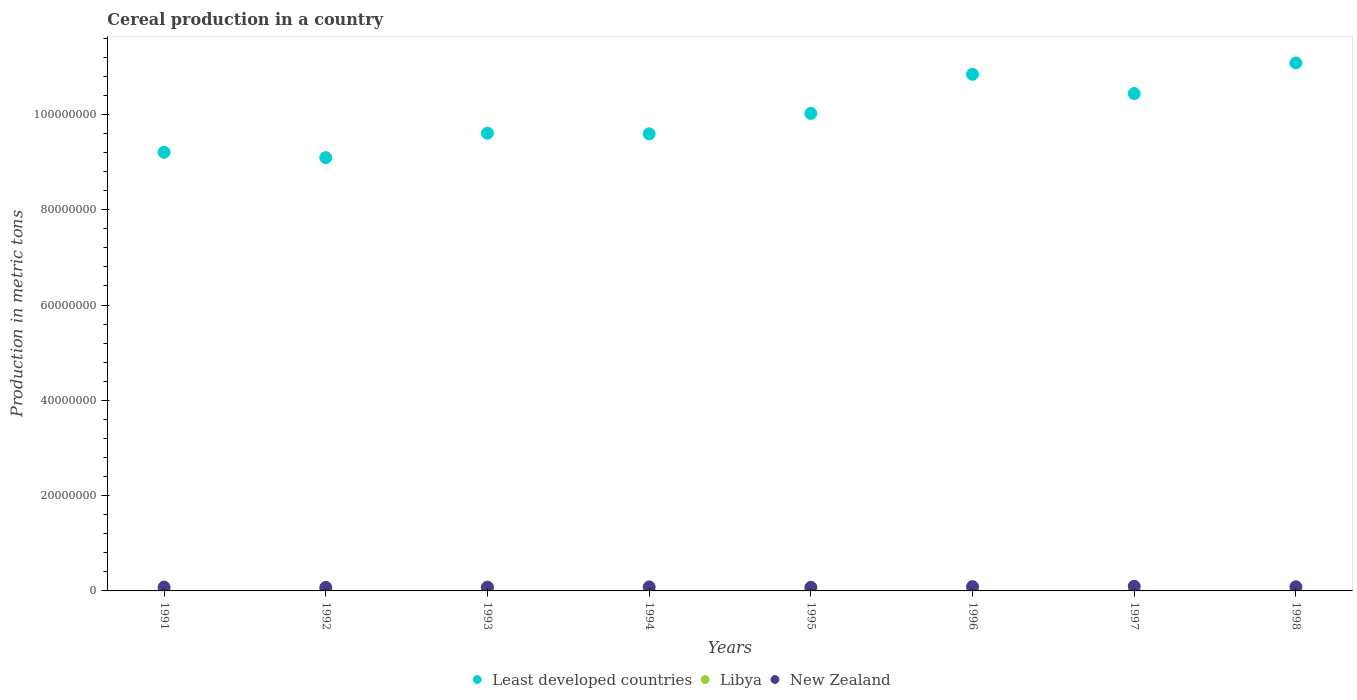Is the number of dotlines equal to the number of legend labels?
Offer a very short reply. Yes. What is the total cereal production in Libya in 1998?
Offer a very short reply. 2.13e+05. Across all years, what is the maximum total cereal production in New Zealand?
Your answer should be compact. 9.80e+05. Across all years, what is the minimum total cereal production in Least developed countries?
Your answer should be very brief. 9.09e+07. In which year was the total cereal production in Least developed countries maximum?
Provide a short and direct response. 1998. In which year was the total cereal production in Libya minimum?
Provide a succinct answer. 1995. What is the total total cereal production in New Zealand in the graph?
Make the answer very short. 6.70e+06. What is the difference between the total cereal production in Least developed countries in 1992 and that in 1997?
Offer a very short reply. -1.35e+07. What is the difference between the total cereal production in New Zealand in 1998 and the total cereal production in Libya in 1991?
Ensure brevity in your answer.  6.11e+05. What is the average total cereal production in Least developed countries per year?
Provide a succinct answer. 9.98e+07. In the year 1997, what is the difference between the total cereal production in New Zealand and total cereal production in Least developed countries?
Provide a succinct answer. -1.03e+08. What is the ratio of the total cereal production in Least developed countries in 1991 to that in 1997?
Ensure brevity in your answer.  0.88. Is the total cereal production in Libya in 1996 less than that in 1998?
Your response must be concise. Yes. What is the difference between the highest and the second highest total cereal production in New Zealand?
Offer a very short reply. 7.61e+04. What is the difference between the highest and the lowest total cereal production in Libya?
Make the answer very short. 1.12e+05. Is it the case that in every year, the sum of the total cereal production in Libya and total cereal production in New Zealand  is greater than the total cereal production in Least developed countries?
Keep it short and to the point. No. Is the total cereal production in Libya strictly greater than the total cereal production in New Zealand over the years?
Provide a short and direct response. No. How many years are there in the graph?
Make the answer very short. 8. Are the values on the major ticks of Y-axis written in scientific E-notation?
Keep it short and to the point. No. Does the graph contain any zero values?
Make the answer very short. No. How many legend labels are there?
Your response must be concise. 3. How are the legend labels stacked?
Offer a very short reply. Horizontal. What is the title of the graph?
Your response must be concise. Cereal production in a country. What is the label or title of the Y-axis?
Keep it short and to the point. Production in metric tons. What is the Production in metric tons in Least developed countries in 1991?
Give a very brief answer. 9.21e+07. What is the Production in metric tons in Libya in 1991?
Offer a very short reply. 2.58e+05. What is the Production in metric tons in New Zealand in 1991?
Make the answer very short. 8.09e+05. What is the Production in metric tons of Least developed countries in 1992?
Offer a terse response. 9.09e+07. What is the Production in metric tons of Libya in 1992?
Your answer should be compact. 2.18e+05. What is the Production in metric tons in New Zealand in 1992?
Your response must be concise. 7.36e+05. What is the Production in metric tons in Least developed countries in 1993?
Offer a terse response. 9.61e+07. What is the Production in metric tons of Libya in 1993?
Give a very brief answer. 1.80e+05. What is the Production in metric tons in New Zealand in 1993?
Offer a terse response. 8.03e+05. What is the Production in metric tons in Least developed countries in 1994?
Make the answer very short. 9.59e+07. What is the Production in metric tons in Libya in 1994?
Your answer should be compact. 1.65e+05. What is the Production in metric tons of New Zealand in 1994?
Provide a short and direct response. 8.43e+05. What is the Production in metric tons of Least developed countries in 1995?
Provide a succinct answer. 1.00e+08. What is the Production in metric tons in Libya in 1995?
Offer a terse response. 1.46e+05. What is the Production in metric tons of New Zealand in 1995?
Offer a terse response. 7.52e+05. What is the Production in metric tons in Least developed countries in 1996?
Offer a very short reply. 1.08e+08. What is the Production in metric tons of Libya in 1996?
Provide a succinct answer. 1.60e+05. What is the Production in metric tons of New Zealand in 1996?
Your response must be concise. 9.04e+05. What is the Production in metric tons of Least developed countries in 1997?
Offer a terse response. 1.04e+08. What is the Production in metric tons in Libya in 1997?
Give a very brief answer. 2.06e+05. What is the Production in metric tons in New Zealand in 1997?
Offer a terse response. 9.80e+05. What is the Production in metric tons of Least developed countries in 1998?
Your answer should be compact. 1.11e+08. What is the Production in metric tons in Libya in 1998?
Make the answer very short. 2.13e+05. What is the Production in metric tons of New Zealand in 1998?
Provide a succinct answer. 8.68e+05. Across all years, what is the maximum Production in metric tons of Least developed countries?
Your answer should be very brief. 1.11e+08. Across all years, what is the maximum Production in metric tons in Libya?
Provide a short and direct response. 2.58e+05. Across all years, what is the maximum Production in metric tons of New Zealand?
Your answer should be compact. 9.80e+05. Across all years, what is the minimum Production in metric tons in Least developed countries?
Offer a terse response. 9.09e+07. Across all years, what is the minimum Production in metric tons of Libya?
Keep it short and to the point. 1.46e+05. Across all years, what is the minimum Production in metric tons of New Zealand?
Give a very brief answer. 7.36e+05. What is the total Production in metric tons of Least developed countries in the graph?
Provide a succinct answer. 7.99e+08. What is the total Production in metric tons of Libya in the graph?
Provide a succinct answer. 1.54e+06. What is the total Production in metric tons in New Zealand in the graph?
Provide a short and direct response. 6.70e+06. What is the difference between the Production in metric tons of Least developed countries in 1991 and that in 1992?
Keep it short and to the point. 1.13e+06. What is the difference between the Production in metric tons of Libya in 1991 and that in 1992?
Your response must be concise. 4.00e+04. What is the difference between the Production in metric tons of New Zealand in 1991 and that in 1992?
Provide a succinct answer. 7.31e+04. What is the difference between the Production in metric tons in Least developed countries in 1991 and that in 1993?
Your response must be concise. -4.00e+06. What is the difference between the Production in metric tons in Libya in 1991 and that in 1993?
Offer a very short reply. 7.80e+04. What is the difference between the Production in metric tons in New Zealand in 1991 and that in 1993?
Your response must be concise. 6235. What is the difference between the Production in metric tons in Least developed countries in 1991 and that in 1994?
Ensure brevity in your answer.  -3.87e+06. What is the difference between the Production in metric tons of Libya in 1991 and that in 1994?
Your answer should be very brief. 9.31e+04. What is the difference between the Production in metric tons in New Zealand in 1991 and that in 1994?
Provide a succinct answer. -3.38e+04. What is the difference between the Production in metric tons in Least developed countries in 1991 and that in 1995?
Ensure brevity in your answer.  -8.15e+06. What is the difference between the Production in metric tons in Libya in 1991 and that in 1995?
Offer a very short reply. 1.12e+05. What is the difference between the Production in metric tons in New Zealand in 1991 and that in 1995?
Provide a short and direct response. 5.73e+04. What is the difference between the Production in metric tons of Least developed countries in 1991 and that in 1996?
Offer a terse response. -1.64e+07. What is the difference between the Production in metric tons in Libya in 1991 and that in 1996?
Your answer should be compact. 9.79e+04. What is the difference between the Production in metric tons in New Zealand in 1991 and that in 1996?
Ensure brevity in your answer.  -9.46e+04. What is the difference between the Production in metric tons in Least developed countries in 1991 and that in 1997?
Your answer should be compact. -1.23e+07. What is the difference between the Production in metric tons in Libya in 1991 and that in 1997?
Offer a terse response. 5.15e+04. What is the difference between the Production in metric tons of New Zealand in 1991 and that in 1997?
Your answer should be compact. -1.71e+05. What is the difference between the Production in metric tons in Least developed countries in 1991 and that in 1998?
Provide a succinct answer. -1.87e+07. What is the difference between the Production in metric tons in Libya in 1991 and that in 1998?
Ensure brevity in your answer.  4.50e+04. What is the difference between the Production in metric tons in New Zealand in 1991 and that in 1998?
Make the answer very short. -5.89e+04. What is the difference between the Production in metric tons in Least developed countries in 1992 and that in 1993?
Ensure brevity in your answer.  -5.12e+06. What is the difference between the Production in metric tons of Libya in 1992 and that in 1993?
Offer a very short reply. 3.81e+04. What is the difference between the Production in metric tons of New Zealand in 1992 and that in 1993?
Offer a very short reply. -6.69e+04. What is the difference between the Production in metric tons in Least developed countries in 1992 and that in 1994?
Give a very brief answer. -5.00e+06. What is the difference between the Production in metric tons of Libya in 1992 and that in 1994?
Give a very brief answer. 5.31e+04. What is the difference between the Production in metric tons in New Zealand in 1992 and that in 1994?
Offer a terse response. -1.07e+05. What is the difference between the Production in metric tons of Least developed countries in 1992 and that in 1995?
Keep it short and to the point. -9.28e+06. What is the difference between the Production in metric tons of Libya in 1992 and that in 1995?
Provide a succinct answer. 7.19e+04. What is the difference between the Production in metric tons of New Zealand in 1992 and that in 1995?
Provide a succinct answer. -1.59e+04. What is the difference between the Production in metric tons in Least developed countries in 1992 and that in 1996?
Offer a terse response. -1.75e+07. What is the difference between the Production in metric tons of Libya in 1992 and that in 1996?
Offer a terse response. 5.80e+04. What is the difference between the Production in metric tons in New Zealand in 1992 and that in 1996?
Provide a succinct answer. -1.68e+05. What is the difference between the Production in metric tons of Least developed countries in 1992 and that in 1997?
Offer a very short reply. -1.35e+07. What is the difference between the Production in metric tons of Libya in 1992 and that in 1997?
Offer a very short reply. 1.16e+04. What is the difference between the Production in metric tons of New Zealand in 1992 and that in 1997?
Your answer should be compact. -2.44e+05. What is the difference between the Production in metric tons of Least developed countries in 1992 and that in 1998?
Offer a terse response. -1.99e+07. What is the difference between the Production in metric tons in Libya in 1992 and that in 1998?
Give a very brief answer. 5061. What is the difference between the Production in metric tons of New Zealand in 1992 and that in 1998?
Offer a terse response. -1.32e+05. What is the difference between the Production in metric tons of Least developed countries in 1993 and that in 1994?
Your answer should be very brief. 1.21e+05. What is the difference between the Production in metric tons in Libya in 1993 and that in 1994?
Offer a very short reply. 1.50e+04. What is the difference between the Production in metric tons in New Zealand in 1993 and that in 1994?
Give a very brief answer. -4.00e+04. What is the difference between the Production in metric tons of Least developed countries in 1993 and that in 1995?
Your answer should be very brief. -4.15e+06. What is the difference between the Production in metric tons of Libya in 1993 and that in 1995?
Provide a short and direct response. 3.39e+04. What is the difference between the Production in metric tons in New Zealand in 1993 and that in 1995?
Provide a succinct answer. 5.11e+04. What is the difference between the Production in metric tons of Least developed countries in 1993 and that in 1996?
Your answer should be compact. -1.24e+07. What is the difference between the Production in metric tons of Libya in 1993 and that in 1996?
Your answer should be very brief. 1.99e+04. What is the difference between the Production in metric tons in New Zealand in 1993 and that in 1996?
Your answer should be very brief. -1.01e+05. What is the difference between the Production in metric tons of Least developed countries in 1993 and that in 1997?
Keep it short and to the point. -8.33e+06. What is the difference between the Production in metric tons of Libya in 1993 and that in 1997?
Offer a terse response. -2.65e+04. What is the difference between the Production in metric tons in New Zealand in 1993 and that in 1997?
Make the answer very short. -1.77e+05. What is the difference between the Production in metric tons in Least developed countries in 1993 and that in 1998?
Offer a very short reply. -1.48e+07. What is the difference between the Production in metric tons of Libya in 1993 and that in 1998?
Your response must be concise. -3.30e+04. What is the difference between the Production in metric tons in New Zealand in 1993 and that in 1998?
Your answer should be very brief. -6.52e+04. What is the difference between the Production in metric tons of Least developed countries in 1994 and that in 1995?
Your answer should be very brief. -4.28e+06. What is the difference between the Production in metric tons of Libya in 1994 and that in 1995?
Make the answer very short. 1.88e+04. What is the difference between the Production in metric tons in New Zealand in 1994 and that in 1995?
Offer a terse response. 9.11e+04. What is the difference between the Production in metric tons of Least developed countries in 1994 and that in 1996?
Ensure brevity in your answer.  -1.25e+07. What is the difference between the Production in metric tons in Libya in 1994 and that in 1996?
Your response must be concise. 4851. What is the difference between the Production in metric tons in New Zealand in 1994 and that in 1996?
Provide a short and direct response. -6.09e+04. What is the difference between the Production in metric tons in Least developed countries in 1994 and that in 1997?
Your answer should be very brief. -8.45e+06. What is the difference between the Production in metric tons of Libya in 1994 and that in 1997?
Your response must be concise. -4.15e+04. What is the difference between the Production in metric tons of New Zealand in 1994 and that in 1997?
Offer a very short reply. -1.37e+05. What is the difference between the Production in metric tons in Least developed countries in 1994 and that in 1998?
Ensure brevity in your answer.  -1.49e+07. What is the difference between the Production in metric tons in Libya in 1994 and that in 1998?
Ensure brevity in your answer.  -4.80e+04. What is the difference between the Production in metric tons of New Zealand in 1994 and that in 1998?
Provide a succinct answer. -2.52e+04. What is the difference between the Production in metric tons of Least developed countries in 1995 and that in 1996?
Provide a short and direct response. -8.21e+06. What is the difference between the Production in metric tons in Libya in 1995 and that in 1996?
Offer a terse response. -1.40e+04. What is the difference between the Production in metric tons in New Zealand in 1995 and that in 1996?
Your response must be concise. -1.52e+05. What is the difference between the Production in metric tons of Least developed countries in 1995 and that in 1997?
Ensure brevity in your answer.  -4.18e+06. What is the difference between the Production in metric tons in Libya in 1995 and that in 1997?
Provide a short and direct response. -6.04e+04. What is the difference between the Production in metric tons in New Zealand in 1995 and that in 1997?
Ensure brevity in your answer.  -2.28e+05. What is the difference between the Production in metric tons in Least developed countries in 1995 and that in 1998?
Make the answer very short. -1.06e+07. What is the difference between the Production in metric tons of Libya in 1995 and that in 1998?
Offer a very short reply. -6.69e+04. What is the difference between the Production in metric tons of New Zealand in 1995 and that in 1998?
Provide a short and direct response. -1.16e+05. What is the difference between the Production in metric tons of Least developed countries in 1996 and that in 1997?
Give a very brief answer. 4.04e+06. What is the difference between the Production in metric tons of Libya in 1996 and that in 1997?
Keep it short and to the point. -4.64e+04. What is the difference between the Production in metric tons of New Zealand in 1996 and that in 1997?
Your answer should be very brief. -7.61e+04. What is the difference between the Production in metric tons of Least developed countries in 1996 and that in 1998?
Offer a terse response. -2.39e+06. What is the difference between the Production in metric tons of Libya in 1996 and that in 1998?
Keep it short and to the point. -5.29e+04. What is the difference between the Production in metric tons in New Zealand in 1996 and that in 1998?
Keep it short and to the point. 3.57e+04. What is the difference between the Production in metric tons of Least developed countries in 1997 and that in 1998?
Your response must be concise. -6.42e+06. What is the difference between the Production in metric tons in Libya in 1997 and that in 1998?
Give a very brief answer. -6500. What is the difference between the Production in metric tons of New Zealand in 1997 and that in 1998?
Keep it short and to the point. 1.12e+05. What is the difference between the Production in metric tons of Least developed countries in 1991 and the Production in metric tons of Libya in 1992?
Offer a terse response. 9.18e+07. What is the difference between the Production in metric tons in Least developed countries in 1991 and the Production in metric tons in New Zealand in 1992?
Your response must be concise. 9.13e+07. What is the difference between the Production in metric tons in Libya in 1991 and the Production in metric tons in New Zealand in 1992?
Provide a short and direct response. -4.78e+05. What is the difference between the Production in metric tons of Least developed countries in 1991 and the Production in metric tons of Libya in 1993?
Your response must be concise. 9.19e+07. What is the difference between the Production in metric tons in Least developed countries in 1991 and the Production in metric tons in New Zealand in 1993?
Keep it short and to the point. 9.13e+07. What is the difference between the Production in metric tons in Libya in 1991 and the Production in metric tons in New Zealand in 1993?
Offer a very short reply. -5.45e+05. What is the difference between the Production in metric tons in Least developed countries in 1991 and the Production in metric tons in Libya in 1994?
Give a very brief answer. 9.19e+07. What is the difference between the Production in metric tons of Least developed countries in 1991 and the Production in metric tons of New Zealand in 1994?
Make the answer very short. 9.12e+07. What is the difference between the Production in metric tons of Libya in 1991 and the Production in metric tons of New Zealand in 1994?
Ensure brevity in your answer.  -5.85e+05. What is the difference between the Production in metric tons in Least developed countries in 1991 and the Production in metric tons in Libya in 1995?
Give a very brief answer. 9.19e+07. What is the difference between the Production in metric tons of Least developed countries in 1991 and the Production in metric tons of New Zealand in 1995?
Your response must be concise. 9.13e+07. What is the difference between the Production in metric tons of Libya in 1991 and the Production in metric tons of New Zealand in 1995?
Keep it short and to the point. -4.94e+05. What is the difference between the Production in metric tons in Least developed countries in 1991 and the Production in metric tons in Libya in 1996?
Offer a very short reply. 9.19e+07. What is the difference between the Production in metric tons of Least developed countries in 1991 and the Production in metric tons of New Zealand in 1996?
Make the answer very short. 9.12e+07. What is the difference between the Production in metric tons of Libya in 1991 and the Production in metric tons of New Zealand in 1996?
Provide a short and direct response. -6.46e+05. What is the difference between the Production in metric tons in Least developed countries in 1991 and the Production in metric tons in Libya in 1997?
Provide a short and direct response. 9.18e+07. What is the difference between the Production in metric tons in Least developed countries in 1991 and the Production in metric tons in New Zealand in 1997?
Provide a succinct answer. 9.11e+07. What is the difference between the Production in metric tons of Libya in 1991 and the Production in metric tons of New Zealand in 1997?
Provide a short and direct response. -7.22e+05. What is the difference between the Production in metric tons of Least developed countries in 1991 and the Production in metric tons of Libya in 1998?
Your response must be concise. 9.18e+07. What is the difference between the Production in metric tons in Least developed countries in 1991 and the Production in metric tons in New Zealand in 1998?
Give a very brief answer. 9.12e+07. What is the difference between the Production in metric tons of Libya in 1991 and the Production in metric tons of New Zealand in 1998?
Your answer should be compact. -6.11e+05. What is the difference between the Production in metric tons of Least developed countries in 1992 and the Production in metric tons of Libya in 1993?
Make the answer very short. 9.07e+07. What is the difference between the Production in metric tons in Least developed countries in 1992 and the Production in metric tons in New Zealand in 1993?
Your answer should be compact. 9.01e+07. What is the difference between the Production in metric tons of Libya in 1992 and the Production in metric tons of New Zealand in 1993?
Your answer should be compact. -5.85e+05. What is the difference between the Production in metric tons in Least developed countries in 1992 and the Production in metric tons in Libya in 1994?
Your answer should be very brief. 9.08e+07. What is the difference between the Production in metric tons of Least developed countries in 1992 and the Production in metric tons of New Zealand in 1994?
Provide a succinct answer. 9.01e+07. What is the difference between the Production in metric tons of Libya in 1992 and the Production in metric tons of New Zealand in 1994?
Your answer should be very brief. -6.25e+05. What is the difference between the Production in metric tons of Least developed countries in 1992 and the Production in metric tons of Libya in 1995?
Provide a short and direct response. 9.08e+07. What is the difference between the Production in metric tons in Least developed countries in 1992 and the Production in metric tons in New Zealand in 1995?
Your response must be concise. 9.02e+07. What is the difference between the Production in metric tons of Libya in 1992 and the Production in metric tons of New Zealand in 1995?
Ensure brevity in your answer.  -5.34e+05. What is the difference between the Production in metric tons in Least developed countries in 1992 and the Production in metric tons in Libya in 1996?
Your response must be concise. 9.08e+07. What is the difference between the Production in metric tons in Least developed countries in 1992 and the Production in metric tons in New Zealand in 1996?
Offer a very short reply. 9.00e+07. What is the difference between the Production in metric tons in Libya in 1992 and the Production in metric tons in New Zealand in 1996?
Offer a very short reply. -6.86e+05. What is the difference between the Production in metric tons in Least developed countries in 1992 and the Production in metric tons in Libya in 1997?
Keep it short and to the point. 9.07e+07. What is the difference between the Production in metric tons in Least developed countries in 1992 and the Production in metric tons in New Zealand in 1997?
Your answer should be very brief. 8.99e+07. What is the difference between the Production in metric tons of Libya in 1992 and the Production in metric tons of New Zealand in 1997?
Offer a terse response. -7.62e+05. What is the difference between the Production in metric tons of Least developed countries in 1992 and the Production in metric tons of Libya in 1998?
Give a very brief answer. 9.07e+07. What is the difference between the Production in metric tons in Least developed countries in 1992 and the Production in metric tons in New Zealand in 1998?
Provide a succinct answer. 9.01e+07. What is the difference between the Production in metric tons in Libya in 1992 and the Production in metric tons in New Zealand in 1998?
Give a very brief answer. -6.51e+05. What is the difference between the Production in metric tons in Least developed countries in 1993 and the Production in metric tons in Libya in 1994?
Your answer should be compact. 9.59e+07. What is the difference between the Production in metric tons of Least developed countries in 1993 and the Production in metric tons of New Zealand in 1994?
Your answer should be very brief. 9.52e+07. What is the difference between the Production in metric tons in Libya in 1993 and the Production in metric tons in New Zealand in 1994?
Your answer should be compact. -6.63e+05. What is the difference between the Production in metric tons of Least developed countries in 1993 and the Production in metric tons of Libya in 1995?
Your answer should be very brief. 9.59e+07. What is the difference between the Production in metric tons of Least developed countries in 1993 and the Production in metric tons of New Zealand in 1995?
Keep it short and to the point. 9.53e+07. What is the difference between the Production in metric tons of Libya in 1993 and the Production in metric tons of New Zealand in 1995?
Give a very brief answer. -5.72e+05. What is the difference between the Production in metric tons in Least developed countries in 1993 and the Production in metric tons in Libya in 1996?
Provide a succinct answer. 9.59e+07. What is the difference between the Production in metric tons of Least developed countries in 1993 and the Production in metric tons of New Zealand in 1996?
Ensure brevity in your answer.  9.51e+07. What is the difference between the Production in metric tons of Libya in 1993 and the Production in metric tons of New Zealand in 1996?
Provide a short and direct response. -7.24e+05. What is the difference between the Production in metric tons of Least developed countries in 1993 and the Production in metric tons of Libya in 1997?
Make the answer very short. 9.58e+07. What is the difference between the Production in metric tons in Least developed countries in 1993 and the Production in metric tons in New Zealand in 1997?
Provide a succinct answer. 9.51e+07. What is the difference between the Production in metric tons in Libya in 1993 and the Production in metric tons in New Zealand in 1997?
Provide a short and direct response. -8.00e+05. What is the difference between the Production in metric tons of Least developed countries in 1993 and the Production in metric tons of Libya in 1998?
Ensure brevity in your answer.  9.58e+07. What is the difference between the Production in metric tons in Least developed countries in 1993 and the Production in metric tons in New Zealand in 1998?
Provide a succinct answer. 9.52e+07. What is the difference between the Production in metric tons of Libya in 1993 and the Production in metric tons of New Zealand in 1998?
Offer a very short reply. -6.89e+05. What is the difference between the Production in metric tons of Least developed countries in 1994 and the Production in metric tons of Libya in 1995?
Give a very brief answer. 9.58e+07. What is the difference between the Production in metric tons of Least developed countries in 1994 and the Production in metric tons of New Zealand in 1995?
Give a very brief answer. 9.52e+07. What is the difference between the Production in metric tons of Libya in 1994 and the Production in metric tons of New Zealand in 1995?
Provide a short and direct response. -5.87e+05. What is the difference between the Production in metric tons in Least developed countries in 1994 and the Production in metric tons in Libya in 1996?
Your answer should be compact. 9.58e+07. What is the difference between the Production in metric tons in Least developed countries in 1994 and the Production in metric tons in New Zealand in 1996?
Your response must be concise. 9.50e+07. What is the difference between the Production in metric tons of Libya in 1994 and the Production in metric tons of New Zealand in 1996?
Keep it short and to the point. -7.39e+05. What is the difference between the Production in metric tons of Least developed countries in 1994 and the Production in metric tons of Libya in 1997?
Provide a succinct answer. 9.57e+07. What is the difference between the Production in metric tons of Least developed countries in 1994 and the Production in metric tons of New Zealand in 1997?
Your answer should be very brief. 9.49e+07. What is the difference between the Production in metric tons in Libya in 1994 and the Production in metric tons in New Zealand in 1997?
Make the answer very short. -8.15e+05. What is the difference between the Production in metric tons in Least developed countries in 1994 and the Production in metric tons in Libya in 1998?
Ensure brevity in your answer.  9.57e+07. What is the difference between the Production in metric tons of Least developed countries in 1994 and the Production in metric tons of New Zealand in 1998?
Give a very brief answer. 9.51e+07. What is the difference between the Production in metric tons in Libya in 1994 and the Production in metric tons in New Zealand in 1998?
Your answer should be very brief. -7.04e+05. What is the difference between the Production in metric tons of Least developed countries in 1995 and the Production in metric tons of Libya in 1996?
Your answer should be compact. 1.00e+08. What is the difference between the Production in metric tons of Least developed countries in 1995 and the Production in metric tons of New Zealand in 1996?
Give a very brief answer. 9.93e+07. What is the difference between the Production in metric tons in Libya in 1995 and the Production in metric tons in New Zealand in 1996?
Your answer should be very brief. -7.58e+05. What is the difference between the Production in metric tons in Least developed countries in 1995 and the Production in metric tons in Libya in 1997?
Ensure brevity in your answer.  1.00e+08. What is the difference between the Production in metric tons in Least developed countries in 1995 and the Production in metric tons in New Zealand in 1997?
Ensure brevity in your answer.  9.92e+07. What is the difference between the Production in metric tons in Libya in 1995 and the Production in metric tons in New Zealand in 1997?
Keep it short and to the point. -8.34e+05. What is the difference between the Production in metric tons in Least developed countries in 1995 and the Production in metric tons in Libya in 1998?
Provide a succinct answer. 1.00e+08. What is the difference between the Production in metric tons of Least developed countries in 1995 and the Production in metric tons of New Zealand in 1998?
Your answer should be very brief. 9.93e+07. What is the difference between the Production in metric tons of Libya in 1995 and the Production in metric tons of New Zealand in 1998?
Your answer should be very brief. -7.22e+05. What is the difference between the Production in metric tons of Least developed countries in 1996 and the Production in metric tons of Libya in 1997?
Give a very brief answer. 1.08e+08. What is the difference between the Production in metric tons in Least developed countries in 1996 and the Production in metric tons in New Zealand in 1997?
Offer a very short reply. 1.07e+08. What is the difference between the Production in metric tons of Libya in 1996 and the Production in metric tons of New Zealand in 1997?
Offer a very short reply. -8.20e+05. What is the difference between the Production in metric tons in Least developed countries in 1996 and the Production in metric tons in Libya in 1998?
Provide a short and direct response. 1.08e+08. What is the difference between the Production in metric tons of Least developed countries in 1996 and the Production in metric tons of New Zealand in 1998?
Ensure brevity in your answer.  1.08e+08. What is the difference between the Production in metric tons of Libya in 1996 and the Production in metric tons of New Zealand in 1998?
Your answer should be compact. -7.08e+05. What is the difference between the Production in metric tons of Least developed countries in 1997 and the Production in metric tons of Libya in 1998?
Make the answer very short. 1.04e+08. What is the difference between the Production in metric tons in Least developed countries in 1997 and the Production in metric tons in New Zealand in 1998?
Offer a terse response. 1.04e+08. What is the difference between the Production in metric tons of Libya in 1997 and the Production in metric tons of New Zealand in 1998?
Offer a terse response. -6.62e+05. What is the average Production in metric tons in Least developed countries per year?
Provide a succinct answer. 9.98e+07. What is the average Production in metric tons in Libya per year?
Provide a succinct answer. 1.93e+05. What is the average Production in metric tons in New Zealand per year?
Offer a terse response. 8.37e+05. In the year 1991, what is the difference between the Production in metric tons in Least developed countries and Production in metric tons in Libya?
Your response must be concise. 9.18e+07. In the year 1991, what is the difference between the Production in metric tons of Least developed countries and Production in metric tons of New Zealand?
Provide a succinct answer. 9.12e+07. In the year 1991, what is the difference between the Production in metric tons in Libya and Production in metric tons in New Zealand?
Offer a terse response. -5.52e+05. In the year 1992, what is the difference between the Production in metric tons in Least developed countries and Production in metric tons in Libya?
Provide a short and direct response. 9.07e+07. In the year 1992, what is the difference between the Production in metric tons in Least developed countries and Production in metric tons in New Zealand?
Your answer should be very brief. 9.02e+07. In the year 1992, what is the difference between the Production in metric tons of Libya and Production in metric tons of New Zealand?
Keep it short and to the point. -5.18e+05. In the year 1993, what is the difference between the Production in metric tons in Least developed countries and Production in metric tons in Libya?
Your answer should be very brief. 9.59e+07. In the year 1993, what is the difference between the Production in metric tons of Least developed countries and Production in metric tons of New Zealand?
Provide a succinct answer. 9.52e+07. In the year 1993, what is the difference between the Production in metric tons of Libya and Production in metric tons of New Zealand?
Your answer should be compact. -6.23e+05. In the year 1994, what is the difference between the Production in metric tons of Least developed countries and Production in metric tons of Libya?
Provide a short and direct response. 9.58e+07. In the year 1994, what is the difference between the Production in metric tons of Least developed countries and Production in metric tons of New Zealand?
Give a very brief answer. 9.51e+07. In the year 1994, what is the difference between the Production in metric tons of Libya and Production in metric tons of New Zealand?
Make the answer very short. -6.78e+05. In the year 1995, what is the difference between the Production in metric tons of Least developed countries and Production in metric tons of Libya?
Offer a terse response. 1.00e+08. In the year 1995, what is the difference between the Production in metric tons in Least developed countries and Production in metric tons in New Zealand?
Make the answer very short. 9.95e+07. In the year 1995, what is the difference between the Production in metric tons of Libya and Production in metric tons of New Zealand?
Give a very brief answer. -6.06e+05. In the year 1996, what is the difference between the Production in metric tons of Least developed countries and Production in metric tons of Libya?
Offer a terse response. 1.08e+08. In the year 1996, what is the difference between the Production in metric tons in Least developed countries and Production in metric tons in New Zealand?
Provide a succinct answer. 1.08e+08. In the year 1996, what is the difference between the Production in metric tons in Libya and Production in metric tons in New Zealand?
Offer a terse response. -7.44e+05. In the year 1997, what is the difference between the Production in metric tons of Least developed countries and Production in metric tons of Libya?
Make the answer very short. 1.04e+08. In the year 1997, what is the difference between the Production in metric tons in Least developed countries and Production in metric tons in New Zealand?
Your response must be concise. 1.03e+08. In the year 1997, what is the difference between the Production in metric tons of Libya and Production in metric tons of New Zealand?
Offer a terse response. -7.74e+05. In the year 1998, what is the difference between the Production in metric tons in Least developed countries and Production in metric tons in Libya?
Your response must be concise. 1.11e+08. In the year 1998, what is the difference between the Production in metric tons of Least developed countries and Production in metric tons of New Zealand?
Provide a succinct answer. 1.10e+08. In the year 1998, what is the difference between the Production in metric tons of Libya and Production in metric tons of New Zealand?
Your answer should be compact. -6.56e+05. What is the ratio of the Production in metric tons of Least developed countries in 1991 to that in 1992?
Your response must be concise. 1.01. What is the ratio of the Production in metric tons in Libya in 1991 to that in 1992?
Provide a short and direct response. 1.18. What is the ratio of the Production in metric tons in New Zealand in 1991 to that in 1992?
Provide a succinct answer. 1.1. What is the ratio of the Production in metric tons in Least developed countries in 1991 to that in 1993?
Ensure brevity in your answer.  0.96. What is the ratio of the Production in metric tons in Libya in 1991 to that in 1993?
Your answer should be compact. 1.43. What is the ratio of the Production in metric tons of New Zealand in 1991 to that in 1993?
Keep it short and to the point. 1.01. What is the ratio of the Production in metric tons of Least developed countries in 1991 to that in 1994?
Provide a short and direct response. 0.96. What is the ratio of the Production in metric tons of Libya in 1991 to that in 1994?
Provide a short and direct response. 1.57. What is the ratio of the Production in metric tons of New Zealand in 1991 to that in 1994?
Provide a succinct answer. 0.96. What is the ratio of the Production in metric tons in Least developed countries in 1991 to that in 1995?
Offer a terse response. 0.92. What is the ratio of the Production in metric tons of Libya in 1991 to that in 1995?
Offer a terse response. 1.77. What is the ratio of the Production in metric tons of New Zealand in 1991 to that in 1995?
Ensure brevity in your answer.  1.08. What is the ratio of the Production in metric tons in Least developed countries in 1991 to that in 1996?
Give a very brief answer. 0.85. What is the ratio of the Production in metric tons in Libya in 1991 to that in 1996?
Ensure brevity in your answer.  1.61. What is the ratio of the Production in metric tons in New Zealand in 1991 to that in 1996?
Offer a very short reply. 0.9. What is the ratio of the Production in metric tons of Least developed countries in 1991 to that in 1997?
Give a very brief answer. 0.88. What is the ratio of the Production in metric tons in Libya in 1991 to that in 1997?
Keep it short and to the point. 1.25. What is the ratio of the Production in metric tons of New Zealand in 1991 to that in 1997?
Offer a very short reply. 0.83. What is the ratio of the Production in metric tons of Least developed countries in 1991 to that in 1998?
Give a very brief answer. 0.83. What is the ratio of the Production in metric tons of Libya in 1991 to that in 1998?
Offer a terse response. 1.21. What is the ratio of the Production in metric tons in New Zealand in 1991 to that in 1998?
Give a very brief answer. 0.93. What is the ratio of the Production in metric tons of Least developed countries in 1992 to that in 1993?
Offer a very short reply. 0.95. What is the ratio of the Production in metric tons of Libya in 1992 to that in 1993?
Provide a succinct answer. 1.21. What is the ratio of the Production in metric tons of Least developed countries in 1992 to that in 1994?
Give a very brief answer. 0.95. What is the ratio of the Production in metric tons of Libya in 1992 to that in 1994?
Your response must be concise. 1.32. What is the ratio of the Production in metric tons of New Zealand in 1992 to that in 1994?
Give a very brief answer. 0.87. What is the ratio of the Production in metric tons in Least developed countries in 1992 to that in 1995?
Provide a short and direct response. 0.91. What is the ratio of the Production in metric tons in Libya in 1992 to that in 1995?
Your answer should be very brief. 1.49. What is the ratio of the Production in metric tons in New Zealand in 1992 to that in 1995?
Offer a terse response. 0.98. What is the ratio of the Production in metric tons in Least developed countries in 1992 to that in 1996?
Your answer should be very brief. 0.84. What is the ratio of the Production in metric tons of Libya in 1992 to that in 1996?
Provide a succinct answer. 1.36. What is the ratio of the Production in metric tons of New Zealand in 1992 to that in 1996?
Offer a very short reply. 0.81. What is the ratio of the Production in metric tons in Least developed countries in 1992 to that in 1997?
Offer a very short reply. 0.87. What is the ratio of the Production in metric tons of Libya in 1992 to that in 1997?
Offer a terse response. 1.06. What is the ratio of the Production in metric tons in New Zealand in 1992 to that in 1997?
Your answer should be compact. 0.75. What is the ratio of the Production in metric tons of Least developed countries in 1992 to that in 1998?
Your response must be concise. 0.82. What is the ratio of the Production in metric tons in Libya in 1992 to that in 1998?
Offer a very short reply. 1.02. What is the ratio of the Production in metric tons in New Zealand in 1992 to that in 1998?
Offer a terse response. 0.85. What is the ratio of the Production in metric tons in Libya in 1993 to that in 1994?
Keep it short and to the point. 1.09. What is the ratio of the Production in metric tons in New Zealand in 1993 to that in 1994?
Make the answer very short. 0.95. What is the ratio of the Production in metric tons in Least developed countries in 1993 to that in 1995?
Your answer should be compact. 0.96. What is the ratio of the Production in metric tons in Libya in 1993 to that in 1995?
Your answer should be very brief. 1.23. What is the ratio of the Production in metric tons of New Zealand in 1993 to that in 1995?
Provide a short and direct response. 1.07. What is the ratio of the Production in metric tons in Least developed countries in 1993 to that in 1996?
Give a very brief answer. 0.89. What is the ratio of the Production in metric tons in Libya in 1993 to that in 1996?
Your answer should be compact. 1.12. What is the ratio of the Production in metric tons in New Zealand in 1993 to that in 1996?
Offer a very short reply. 0.89. What is the ratio of the Production in metric tons of Least developed countries in 1993 to that in 1997?
Give a very brief answer. 0.92. What is the ratio of the Production in metric tons of Libya in 1993 to that in 1997?
Provide a short and direct response. 0.87. What is the ratio of the Production in metric tons of New Zealand in 1993 to that in 1997?
Provide a short and direct response. 0.82. What is the ratio of the Production in metric tons in Least developed countries in 1993 to that in 1998?
Offer a terse response. 0.87. What is the ratio of the Production in metric tons of Libya in 1993 to that in 1998?
Offer a very short reply. 0.84. What is the ratio of the Production in metric tons in New Zealand in 1993 to that in 1998?
Your response must be concise. 0.92. What is the ratio of the Production in metric tons of Least developed countries in 1994 to that in 1995?
Offer a terse response. 0.96. What is the ratio of the Production in metric tons of Libya in 1994 to that in 1995?
Give a very brief answer. 1.13. What is the ratio of the Production in metric tons of New Zealand in 1994 to that in 1995?
Provide a short and direct response. 1.12. What is the ratio of the Production in metric tons in Least developed countries in 1994 to that in 1996?
Your response must be concise. 0.88. What is the ratio of the Production in metric tons of Libya in 1994 to that in 1996?
Your answer should be compact. 1.03. What is the ratio of the Production in metric tons in New Zealand in 1994 to that in 1996?
Your answer should be compact. 0.93. What is the ratio of the Production in metric tons in Least developed countries in 1994 to that in 1997?
Your answer should be compact. 0.92. What is the ratio of the Production in metric tons in Libya in 1994 to that in 1997?
Make the answer very short. 0.8. What is the ratio of the Production in metric tons of New Zealand in 1994 to that in 1997?
Give a very brief answer. 0.86. What is the ratio of the Production in metric tons of Least developed countries in 1994 to that in 1998?
Offer a very short reply. 0.87. What is the ratio of the Production in metric tons of Libya in 1994 to that in 1998?
Give a very brief answer. 0.77. What is the ratio of the Production in metric tons of Least developed countries in 1995 to that in 1996?
Provide a short and direct response. 0.92. What is the ratio of the Production in metric tons in Libya in 1995 to that in 1996?
Ensure brevity in your answer.  0.91. What is the ratio of the Production in metric tons in New Zealand in 1995 to that in 1996?
Make the answer very short. 0.83. What is the ratio of the Production in metric tons of Libya in 1995 to that in 1997?
Provide a short and direct response. 0.71. What is the ratio of the Production in metric tons in New Zealand in 1995 to that in 1997?
Provide a short and direct response. 0.77. What is the ratio of the Production in metric tons of Least developed countries in 1995 to that in 1998?
Your answer should be compact. 0.9. What is the ratio of the Production in metric tons in Libya in 1995 to that in 1998?
Your response must be concise. 0.69. What is the ratio of the Production in metric tons of New Zealand in 1995 to that in 1998?
Keep it short and to the point. 0.87. What is the ratio of the Production in metric tons in Least developed countries in 1996 to that in 1997?
Make the answer very short. 1.04. What is the ratio of the Production in metric tons of Libya in 1996 to that in 1997?
Give a very brief answer. 0.78. What is the ratio of the Production in metric tons in New Zealand in 1996 to that in 1997?
Ensure brevity in your answer.  0.92. What is the ratio of the Production in metric tons of Least developed countries in 1996 to that in 1998?
Ensure brevity in your answer.  0.98. What is the ratio of the Production in metric tons of Libya in 1996 to that in 1998?
Give a very brief answer. 0.75. What is the ratio of the Production in metric tons of New Zealand in 1996 to that in 1998?
Offer a terse response. 1.04. What is the ratio of the Production in metric tons of Least developed countries in 1997 to that in 1998?
Make the answer very short. 0.94. What is the ratio of the Production in metric tons in Libya in 1997 to that in 1998?
Your answer should be very brief. 0.97. What is the ratio of the Production in metric tons of New Zealand in 1997 to that in 1998?
Give a very brief answer. 1.13. What is the difference between the highest and the second highest Production in metric tons of Least developed countries?
Ensure brevity in your answer.  2.39e+06. What is the difference between the highest and the second highest Production in metric tons in Libya?
Your answer should be compact. 4.00e+04. What is the difference between the highest and the second highest Production in metric tons of New Zealand?
Keep it short and to the point. 7.61e+04. What is the difference between the highest and the lowest Production in metric tons of Least developed countries?
Keep it short and to the point. 1.99e+07. What is the difference between the highest and the lowest Production in metric tons of Libya?
Offer a very short reply. 1.12e+05. What is the difference between the highest and the lowest Production in metric tons in New Zealand?
Provide a short and direct response. 2.44e+05. 